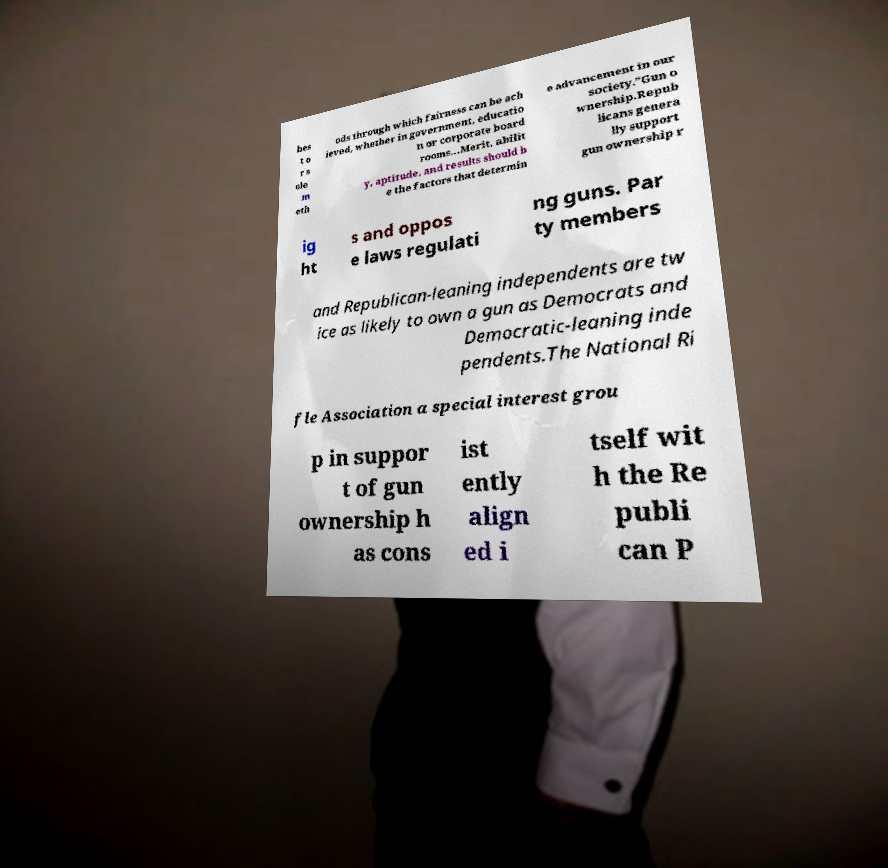Could you extract and type out the text from this image? bes t o r s ole m eth ods through which fairness can be ach ieved, whether in government, educatio n or corporate board rooms…Merit, abilit y, aptitude, and results should b e the factors that determin e advancement in our society.”Gun o wnership.Repub licans genera lly support gun ownership r ig ht s and oppos e laws regulati ng guns. Par ty members and Republican-leaning independents are tw ice as likely to own a gun as Democrats and Democratic-leaning inde pendents.The National Ri fle Association a special interest grou p in suppor t of gun ownership h as cons ist ently align ed i tself wit h the Re publi can P 